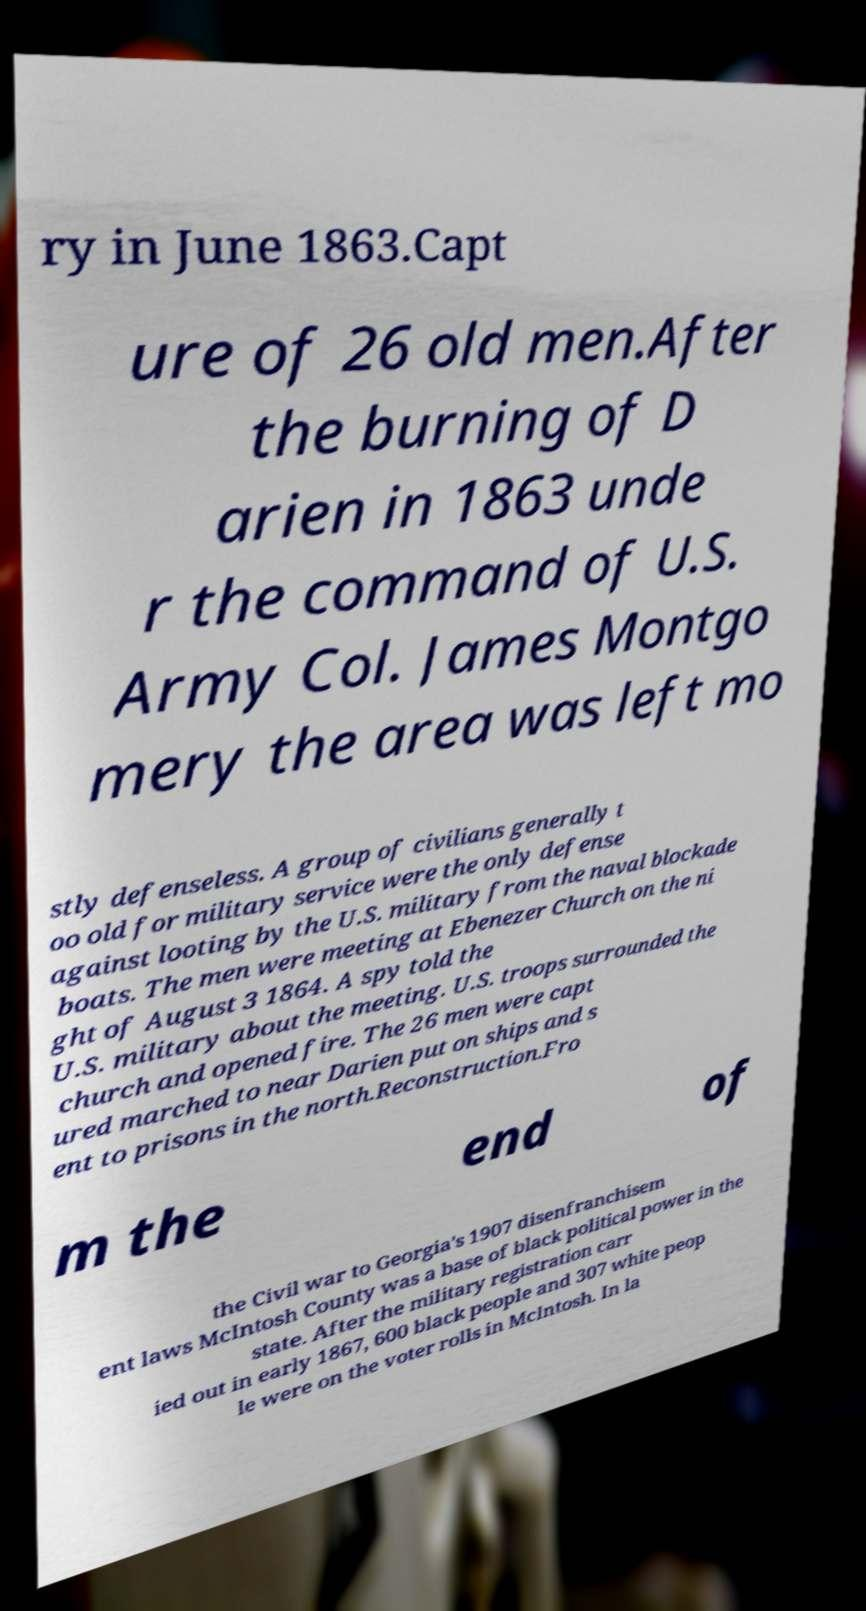Can you accurately transcribe the text from the provided image for me? ry in June 1863.Capt ure of 26 old men.After the burning of D arien in 1863 unde r the command of U.S. Army Col. James Montgo mery the area was left mo stly defenseless. A group of civilians generally t oo old for military service were the only defense against looting by the U.S. military from the naval blockade boats. The men were meeting at Ebenezer Church on the ni ght of August 3 1864. A spy told the U.S. military about the meeting. U.S. troops surrounded the church and opened fire. The 26 men were capt ured marched to near Darien put on ships and s ent to prisons in the north.Reconstruction.Fro m the end of the Civil war to Georgia's 1907 disenfranchisem ent laws McIntosh County was a base of black political power in the state. After the military registration carr ied out in early 1867, 600 black people and 307 white peop le were on the voter rolls in McIntosh. In la 